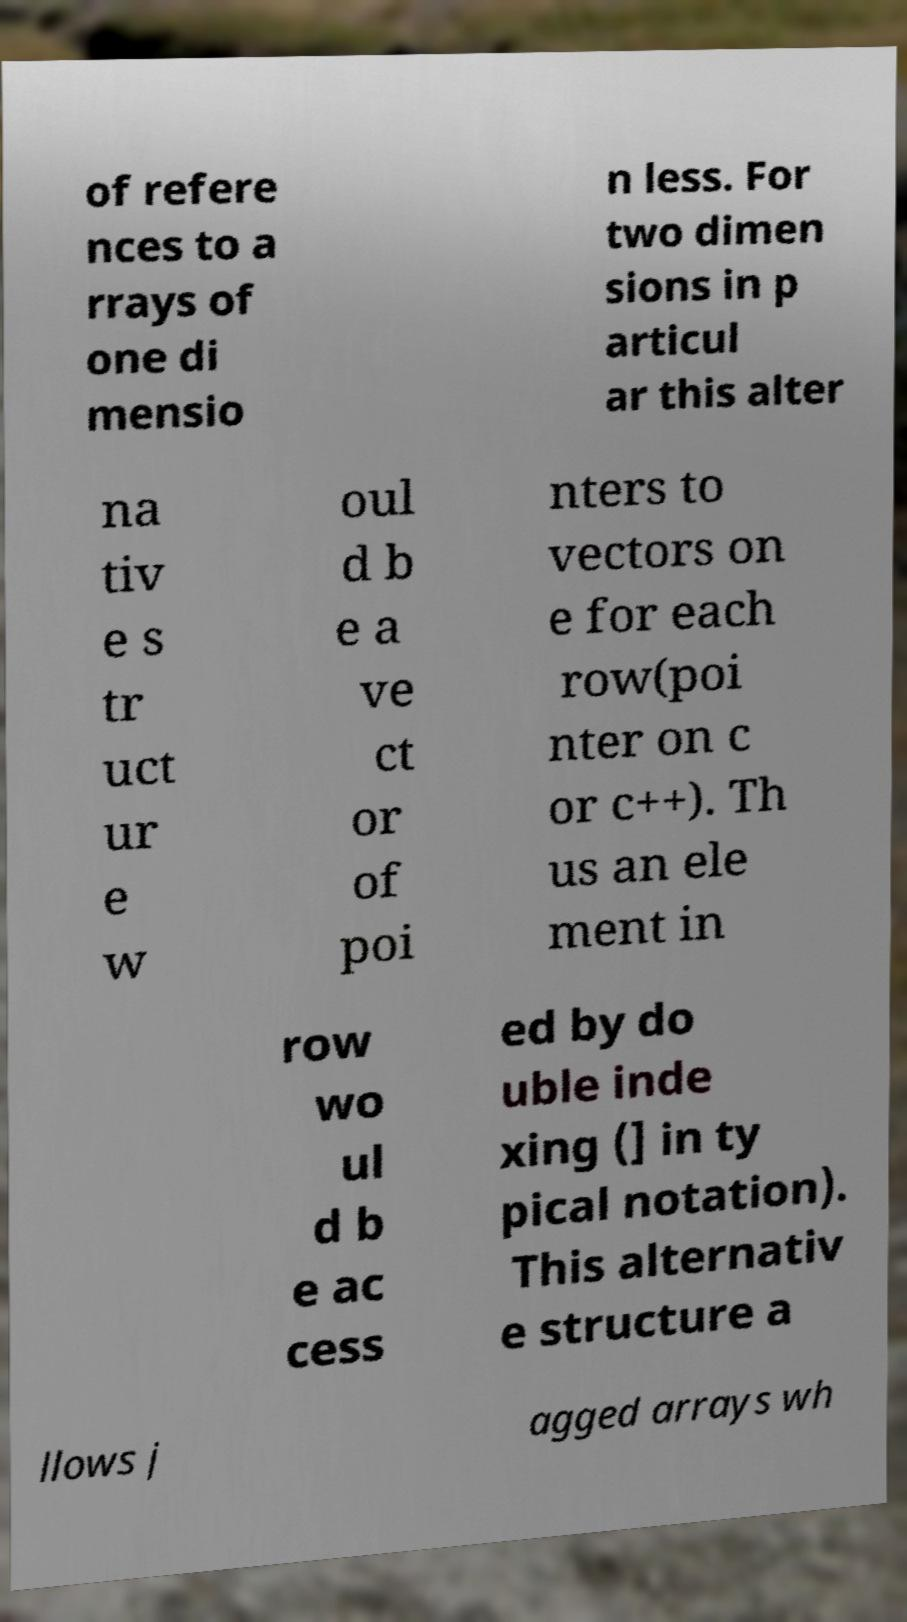There's text embedded in this image that I need extracted. Can you transcribe it verbatim? of refere nces to a rrays of one di mensio n less. For two dimen sions in p articul ar this alter na tiv e s tr uct ur e w oul d b e a ve ct or of poi nters to vectors on e for each row(poi nter on c or c++). Th us an ele ment in row wo ul d b e ac cess ed by do uble inde xing (] in ty pical notation). This alternativ e structure a llows j agged arrays wh 